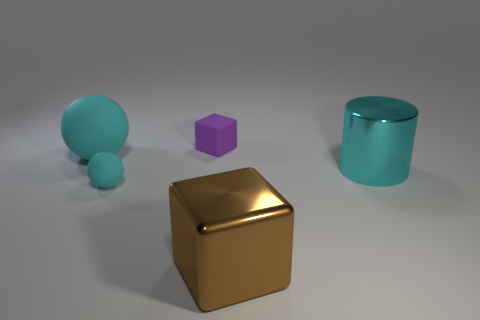Subtract all cyan balls. How many were subtracted if there are1cyan balls left? 1 Subtract all brown balls. Subtract all brown cylinders. How many balls are left? 2 Add 4 big cubes. How many objects exist? 9 Subtract all blocks. How many objects are left? 3 Add 1 tiny rubber cubes. How many tiny rubber cubes are left? 2 Add 1 metal things. How many metal things exist? 3 Subtract 0 green blocks. How many objects are left? 5 Subtract all big spheres. Subtract all purple rubber objects. How many objects are left? 3 